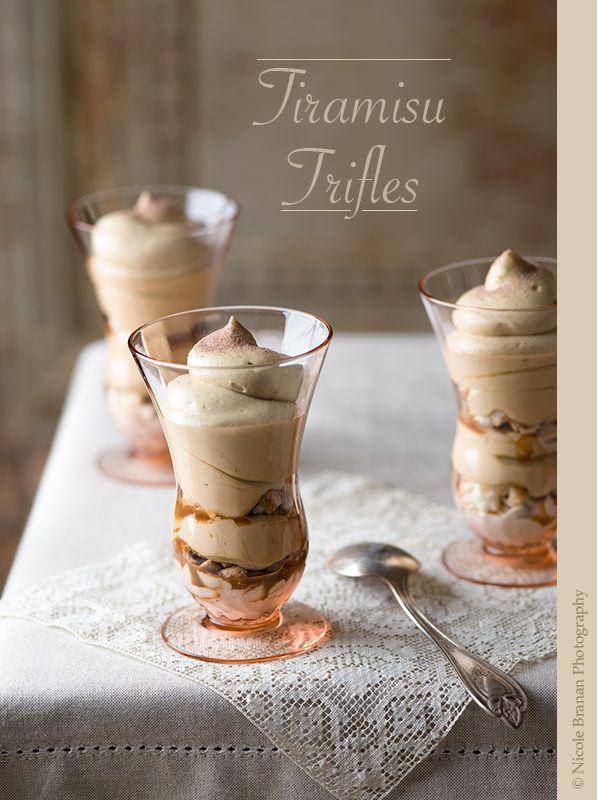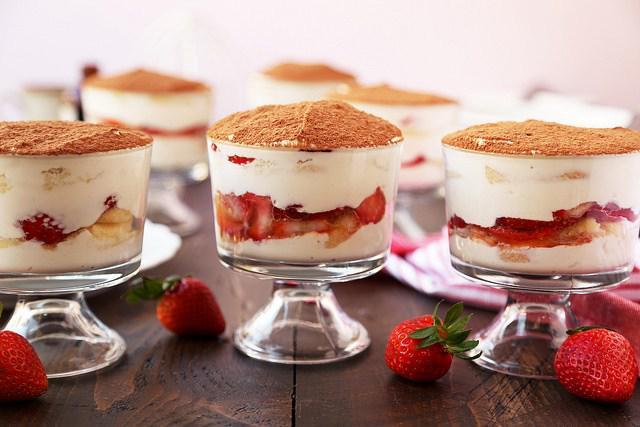The first image is the image on the left, the second image is the image on the right. For the images displayed, is the sentence "# glasses are filed with cream and fruit." factually correct? Answer yes or no. Yes. The first image is the image on the left, the second image is the image on the right. Examine the images to the left and right. Is the description "In both pictures on the right side, there are three glasses the contain layers of chocolate and whipped cream topped with cookie crumbles." accurate? Answer yes or no. No. 